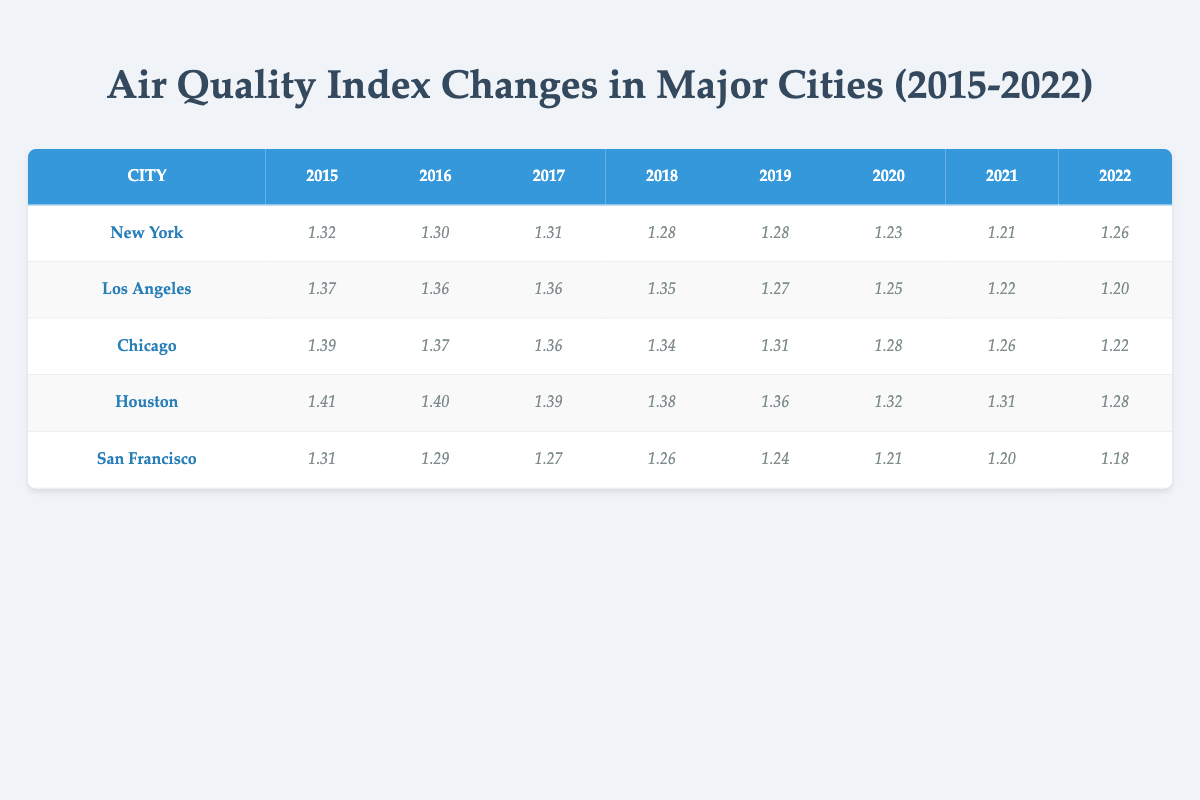What was the Air Quality Index for New York in 2020? According to the table, the value for New York in 2020 is noted as 3.43.
Answer: 3.43 What was the highest Air Quality Index recorded for Chicago during the years shown? By examining the table, the highest recorded value for Chicago is in 2015, which is 4.01.
Answer: 4.01 Is the Air Quality Index for San Francisco decreasing consistently from 2015 to 2022? By looking at the values for San Francisco from 2015 to 2022 (3.69, 3.64, 3.56, 3.53, 3.47, 3.37, 3.33, 3.26), we see a consistent decrease each year.
Answer: Yes What is the difference in Air Quality Index for Houston between 2015 and 2022? For Houston, the value in 2015 is 4.09 and in 2022 is 3.61. The difference is calculated as 4.09 - 3.61 = 0.48.
Answer: 0.48 Calculate the average Air Quality Index across all cities in 2019. The values for 2019 are: New York (3.58), Los Angeles (3.56), Chicago (3.69), Houston (3.91), and San Francisco (3.47). First, we sum these values: 3.58 + 3.56 + 3.69 + 3.91 + 3.47 = 18.21. Then, we divide by 5 (the number of cities) to get the average: 18.21 / 5 = 3.642.
Answer: 3.642 Was the Air Quality Index for New York lower than that of Houston in 2021? The value for New York in 2021 is 3.37, and for Houston, it is 3.69. Since 3.37 is less than 3.69, the statement is true.
Answer: Yes Which city had the highest Air Quality Index in 2021, and what was that value? In the table, the values for 2021 are: New York (3.37), Los Angeles (3.40), Chicago (3.53), Houston (3.69), and San Francisco (3.33). The highest among these is Houston with 3.69.
Answer: Houston, 3.69 Identify the year with the lowest overall Air Quality Index for Los Angeles. Upon reviewing the values for Los Angeles (3.95, 3.91, 3.89, 3.85, 3.56, 3.50, 3.40, 3.33), the lowest occurred in 2022 at 3.33.
Answer: 2022 What can be inferred about air quality trends from 2015 to 2022 across major cities? Analyzing the trends from the table shows that most cities exhibit a decrease in Air Quality Index over the years, suggesting a general decline in air quality across these major cities.
Answer: General decline in air quality 